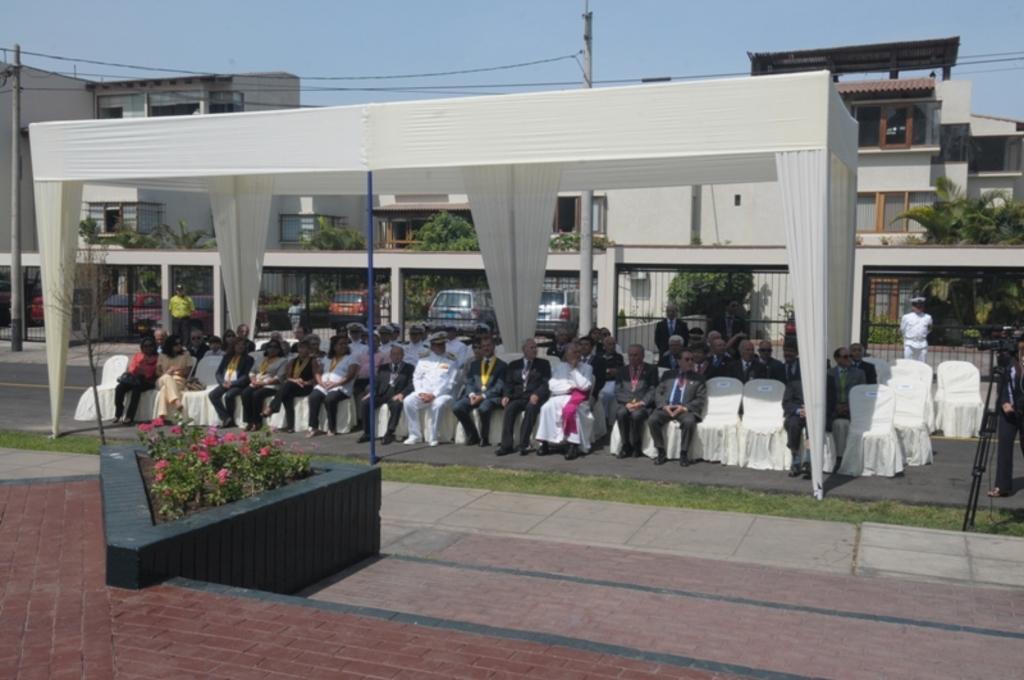Please provide a concise description of this image. This picture is clicked outside the city. In the middle of the picture, we see people sitting on the chairs under a white tent like. Behind that, we see an iron railing. Behind that, we see plants, trees and buildings. We see an electric poles and wires. We see cars parked on the road. At the bottom of the picture, we see plants which have flowers. These flowers are in red color. On the right side, we see a man is standing beside the camera stand. 